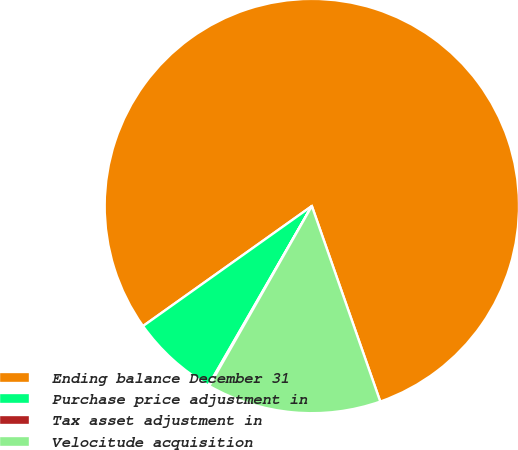Convert chart. <chart><loc_0><loc_0><loc_500><loc_500><pie_chart><fcel>Ending balance December 31<fcel>Purchase price adjustment in<fcel>Tax asset adjustment in<fcel>Velocitude acquisition<nl><fcel>79.48%<fcel>6.84%<fcel>0.08%<fcel>13.6%<nl></chart> 